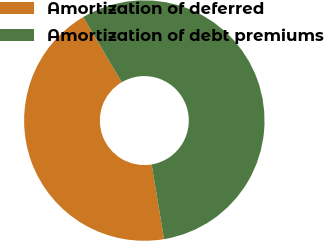<chart> <loc_0><loc_0><loc_500><loc_500><pie_chart><fcel>Amortization of deferred<fcel>Amortization of debt premiums<nl><fcel>44.15%<fcel>55.85%<nl></chart> 